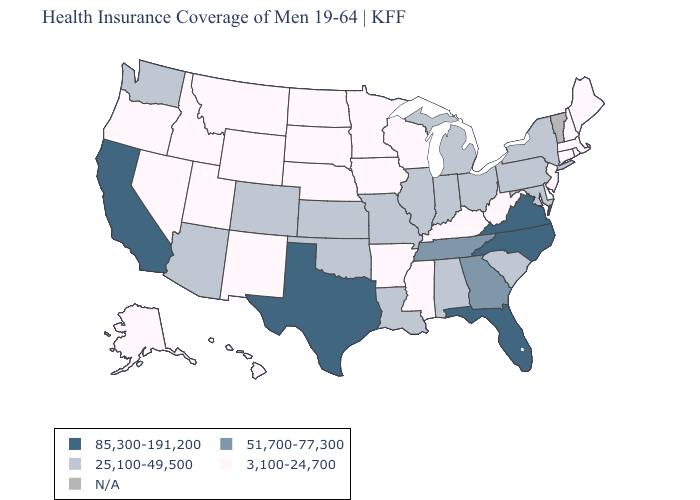Which states have the lowest value in the USA?
Short answer required. Alaska, Arkansas, Connecticut, Delaware, Hawaii, Idaho, Iowa, Kentucky, Maine, Massachusetts, Minnesota, Mississippi, Montana, Nebraska, Nevada, New Hampshire, New Jersey, New Mexico, North Dakota, Oregon, Rhode Island, South Dakota, Utah, West Virginia, Wisconsin, Wyoming. Does Florida have the lowest value in the USA?
Be succinct. No. Name the states that have a value in the range 85,300-191,200?
Be succinct. California, Florida, North Carolina, Texas, Virginia. What is the value of Florida?
Keep it brief. 85,300-191,200. What is the value of Wisconsin?
Give a very brief answer. 3,100-24,700. What is the value of Washington?
Concise answer only. 25,100-49,500. What is the lowest value in states that border Minnesota?
Give a very brief answer. 3,100-24,700. Name the states that have a value in the range 85,300-191,200?
Answer briefly. California, Florida, North Carolina, Texas, Virginia. Which states hav the highest value in the West?
Quick response, please. California. Among the states that border Maine , which have the highest value?
Be succinct. New Hampshire. Name the states that have a value in the range 51,700-77,300?
Concise answer only. Georgia, Tennessee. Name the states that have a value in the range 25,100-49,500?
Short answer required. Alabama, Arizona, Colorado, Illinois, Indiana, Kansas, Louisiana, Maryland, Michigan, Missouri, New York, Ohio, Oklahoma, Pennsylvania, South Carolina, Washington. Does the map have missing data?
Keep it brief. Yes. 